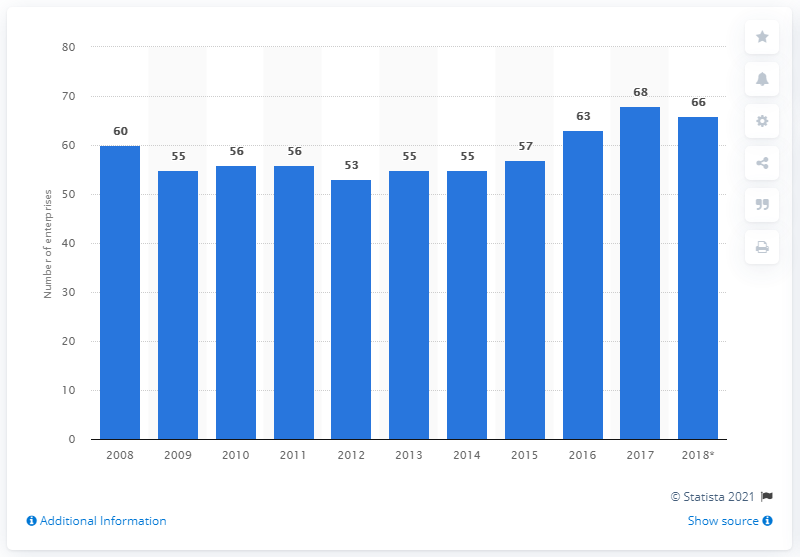Identify some key points in this picture. In 2018, there were 66 enterprises operating in Denmark's cocoa, chocolate and sugar confectionery industry. 